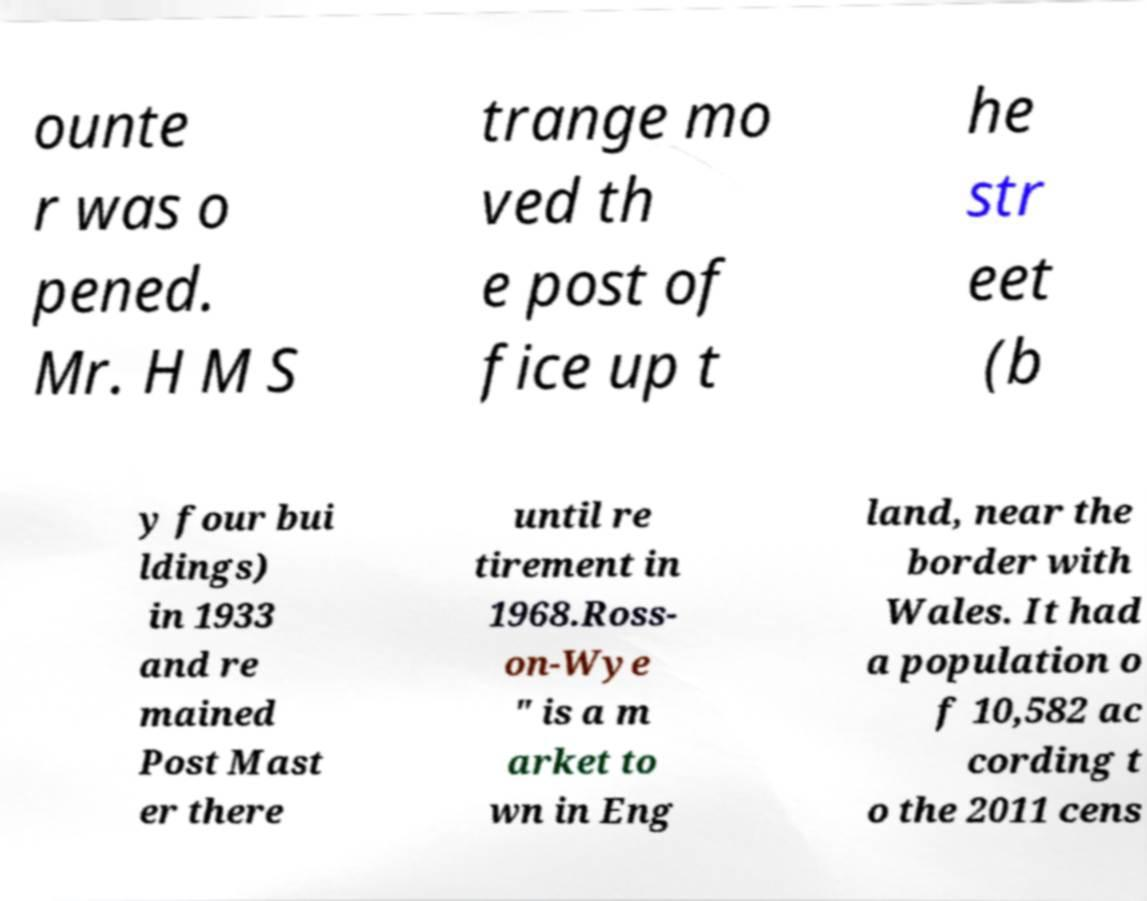Could you extract and type out the text from this image? ounte r was o pened. Mr. H M S trange mo ved th e post of fice up t he str eet (b y four bui ldings) in 1933 and re mained Post Mast er there until re tirement in 1968.Ross- on-Wye " is a m arket to wn in Eng land, near the border with Wales. It had a population o f 10,582 ac cording t o the 2011 cens 